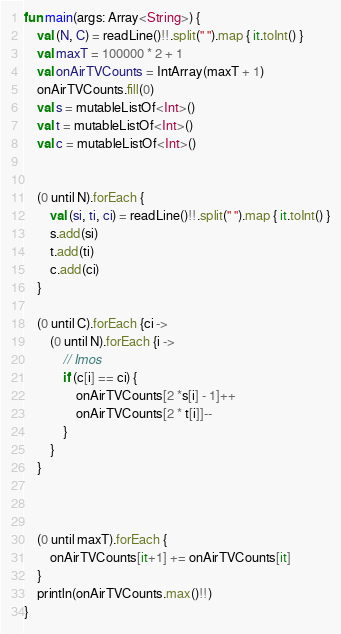Convert code to text. <code><loc_0><loc_0><loc_500><loc_500><_Kotlin_>fun main(args: Array<String>) {
    val (N, C) = readLine()!!.split(" ").map { it.toInt() }
    val maxT = 100000 * 2 + 1
    val onAirTVCounts = IntArray(maxT + 1)
    onAirTVCounts.fill(0)
    val s = mutableListOf<Int>()
    val t = mutableListOf<Int>()
    val c = mutableListOf<Int>()


    (0 until N).forEach {
        val (si, ti, ci) = readLine()!!.split(" ").map { it.toInt() }
        s.add(si)
        t.add(ti)
        c.add(ci)
    }

    (0 until C).forEach {ci ->
        (0 until N).forEach {i ->
            // Imos
            if (c[i] == ci) {
                onAirTVCounts[2 *s[i] - 1]++
                onAirTVCounts[2 * t[i]]--
            }
        }
    }



    (0 until maxT).forEach {
        onAirTVCounts[it+1] += onAirTVCounts[it]
    }
    println(onAirTVCounts.max()!!)
}
</code> 